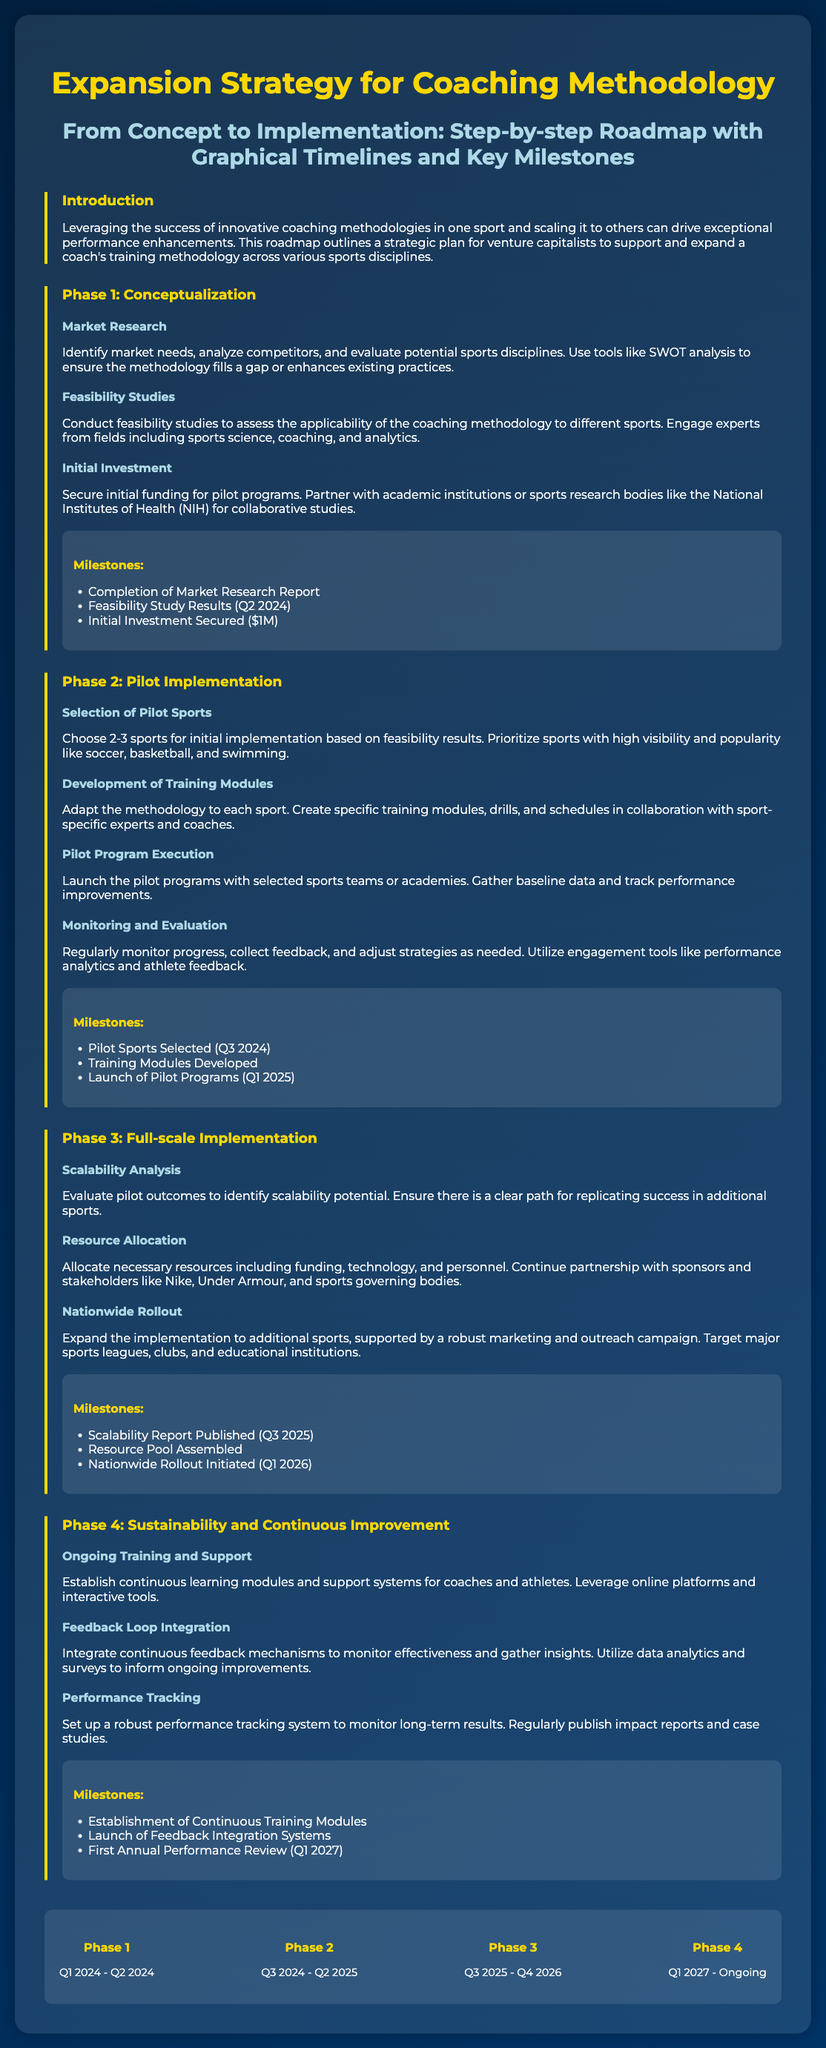what is the title of the poster? The title of the poster is presented at the top in large font, summarizing its main focus.
Answer: Expansion Strategy for Coaching Methodology what is the first phase in the roadmap? The first phase is discussed in detail and outlines initial steps in the expansion strategy.
Answer: Conceptualization how much initial investment is secured for pilot programs? This information is specified as part of the financial planning for the methodology.
Answer: $1M which sports are prioritized for pilot implementation? The document mentions these sports specifically as high visibility and popularity choices.
Answer: Soccer, basketball, swimming when is the feedback integration system launched? This is mentioned as a milestone for ongoing improvements in the methodology.
Answer: Q1 2027 what is the duration of Phase 3? The timeline for this phase is explicitly indicated in the document.
Answer: Q3 2025 - Q4 2026 how many phases are outlined in the expansion strategy? The total number of phases can be inferred from the structured sections in the document.
Answer: Four what is included in the milestones of Phase 2? Milestones specific to this phase are listed clearly, showing key achievements.
Answer: Pilot Sports Selected, Training Modules Developed, Launch of Pilot Programs what type of analysis is performed during Phase 1? The analysis type is outlined in the steps related to understanding market needs and competition.
Answer: Market Research 